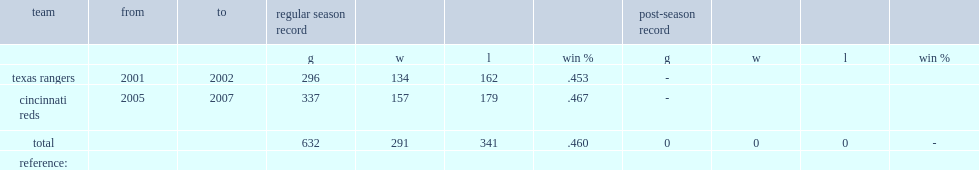What was narron's record with the reds(wins and losses)? 157.0 179.0. 